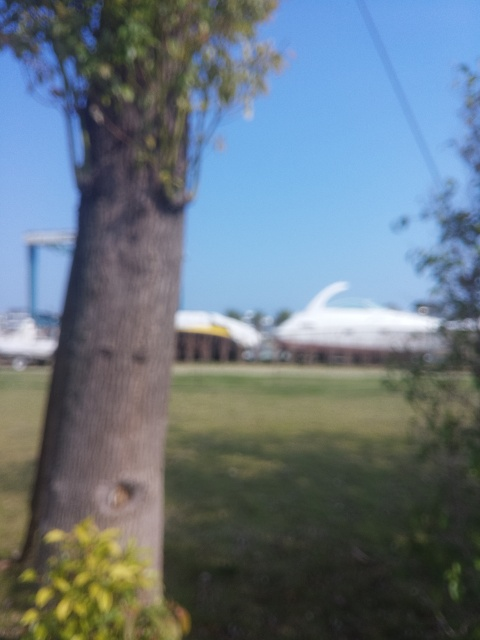Can you give me tips on how to avoid taking blurry photographs? Absolutely. To avoid blurry photographs, ensure your camera's shutter speed is fast enough to freeze any motion, especially if you're hand-holding the camera. Use a tripod or stabilizer if needed. Set your autofocus point to the subject you want to be sharp or use manual focus for more control. Also, use an appropriate aperture for the depth of field you desire, and make sure there's sufficient light hitting your subject. Finally, gently press the shutter button to take the photo, avoiding any unnecessary camera movement.  Could the blur in this image be intentional for artistic reasons? Yes, photographers sometimes intentionally use blur to create a sense of movement, emphasize the subject by blurring the background, or to invoke a dreamy, ethereal atmosphere in the image. However, it's important that this technique is used purposefully. In the context of this image, without additional context, it's difficult to ascertain whether the blur was an artistic choice or an error in focusing. 